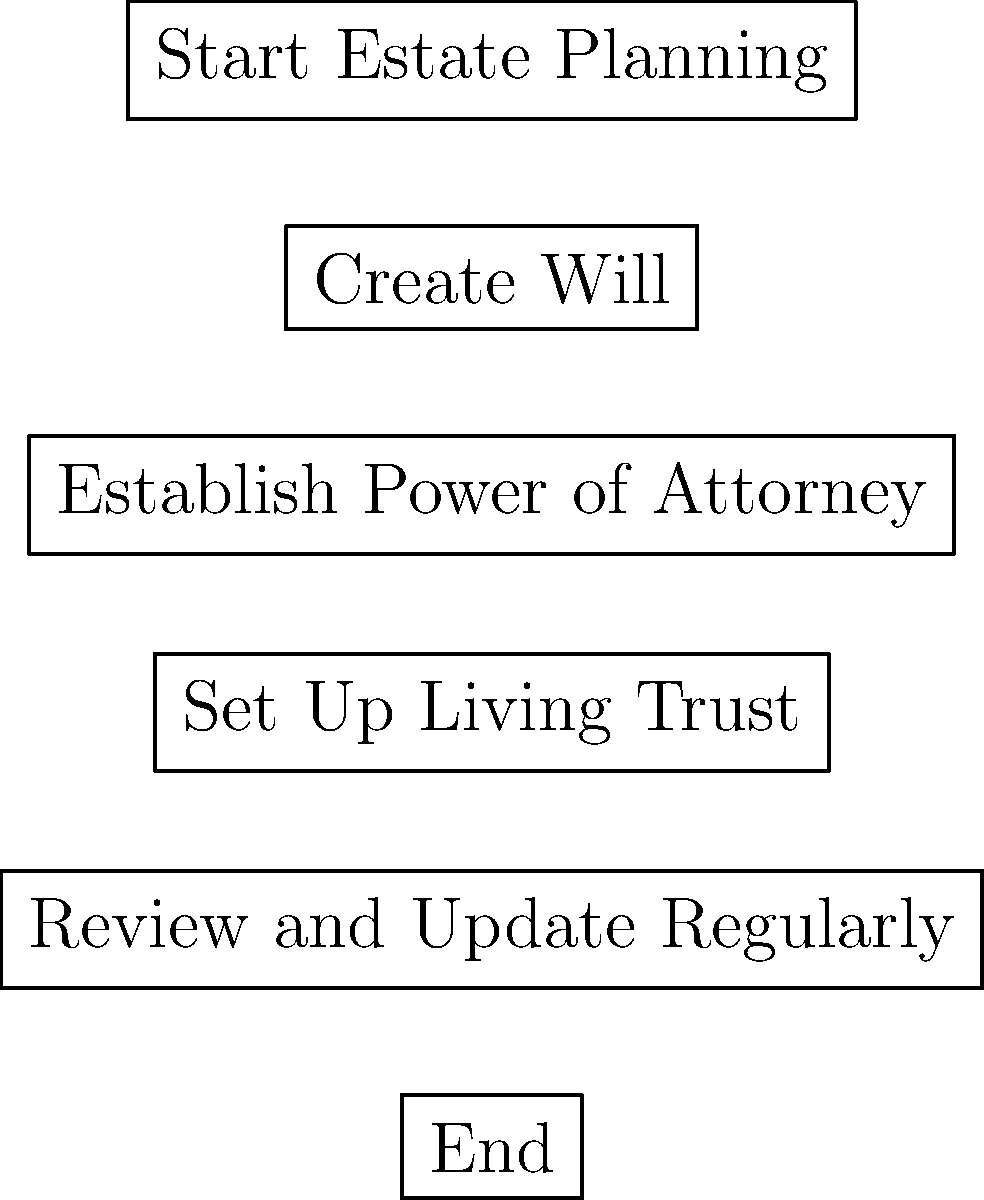In the estate planning flowchart, which step comes immediately after creating a will? Let's analyze the flowchart step-by-step:

1. The flowchart begins with "Start Estate Planning."
2. The first concrete step is "Create Will."
3. Immediately following "Create Will" is "Establish Power of Attorney."
4. After that, we see "Set Up Living Trust."
5. The next step is "Review and Update Regularly."
6. The flowchart ends with "End."

By following the arrows in the flowchart, we can see that the step immediately after "Create Will" is "Establish Power of Attorney." This is an important step in estate planning, as it designates someone to make financial and/or medical decisions on your behalf if you become incapacitated.

Understanding this sequence is crucial for a younger sibling interested in learning about estate planning. It shows that while creating a will is often the first major step, it's followed closely by establishing a power of attorney, which provides important protections during one's lifetime.
Answer: Establish Power of Attorney 